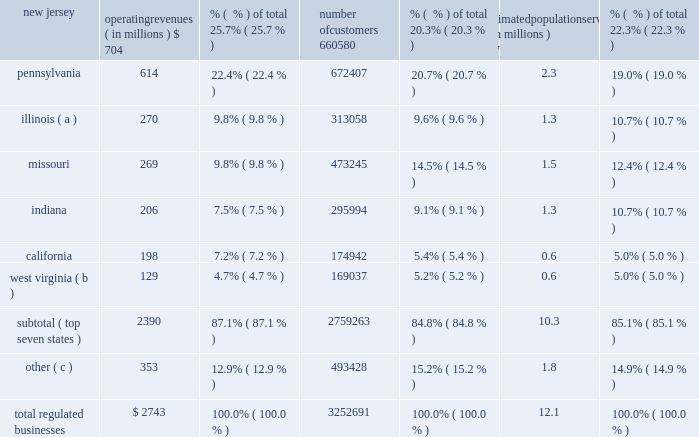Part i item 1 .
Business our company founded in 1886 , american water works company , inc .
( the 201ccompany 201d or 201camerican water 201d ) is a holding company incorporated in delaware .
American water is the largest and most geographically diverse investor owned publicly-traded united states water and wastewater utility company , as measured by both operating revenues and population served .
We employ approximately 6700 professionals who provide drinking water , wastewater and other related services to an estimated 15 million people in 47 states , the district of columbia and ontario , canada .
Operating segments we conduct our business primarily through our regulated businesses segment .
We also operate several market-based businesses that provide a broad range of related and complementary water and wastewater services , which include four operating segments that individually do not meet the criteria of a reportable segment in accordance with generally accepted accounting principles in the united states ( 201cgaap 201d ) .
These four non- reportable operating segments are collectively presented as our 201cmarket-based businesses , 201d which is consistent with how management assesses the results of these businesses .
Additional information can be found in item 7 2014management 2019s discussion and analysis of financial condition and results of operations and note 19 2014segment information in the notes to consolidated financial statements .
Regulated businesses our primary business involves the ownership of subsidiaries that provide water and wastewater utility services to residential , commercial , industrial and other customers , including sale for resale and public authority customers .
Our subsidiaries that provide these services operate in approximately 1600 communities in 16 states in the united states and are generally subject to regulation by certain state commissions or other entities engaged in utility regulation , referred to as public utility commissions or ( 201cpucs 201d ) .
The federal and state governments also regulate environmental , health and safety , and water quality matters .
We report the results of the services provided by our utilities in our regulated businesses segment .
Our regulated businesses segment 2019s operating revenues were $ 2743 million for 2015 , $ 2674 million for 2014 and $ 2594 million for 2013 , accounting for 86.8% ( 86.8 % ) , 88.8% ( 88.8 % ) and 90.1% ( 90.1 % ) , respectively , of total operating revenues for the same periods .
The table summarizes our regulated businesses 2019 operating revenues , number of customers and estimated population served by state , each as of december 31 , 2015 : operating revenues ( in millions ) % (  % ) of total number of customers % (  % ) of total estimated population served ( in millions ) % (  % ) of total .
( a ) includes illinois-american water company and american lake water company .
( b ) includes west virginia-american water company and its subsidiary bluefield valley water works company .
( c ) includes data from our utilities in the following states : georgia , hawaii , iowa , kentucky , maryland , michigan , new york , tennessee and virginia. .
What is the approximate customer penetration in the west virginia market area? 
Computations: (169037 / (0.6 * 1000000))
Answer: 0.28173. 